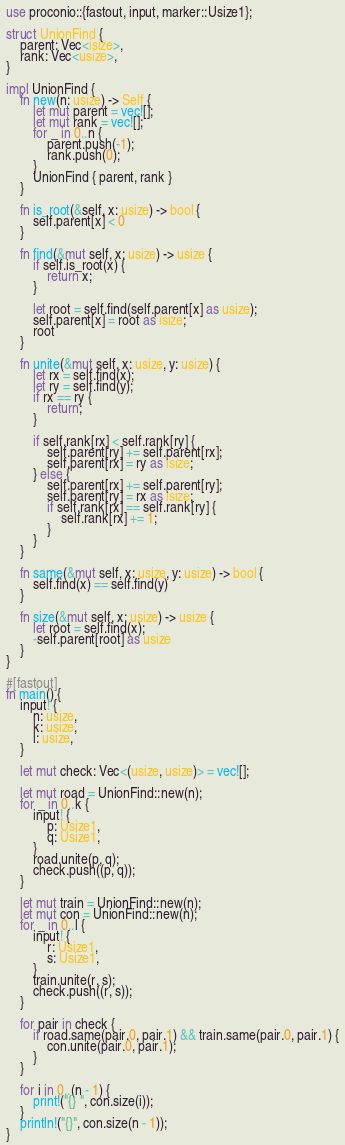<code> <loc_0><loc_0><loc_500><loc_500><_Rust_>use proconio::{fastout, input, marker::Usize1};

struct UnionFind {
    parent: Vec<isize>,
    rank: Vec<usize>,
}

impl UnionFind {
    fn new(n: usize) -> Self {
        let mut parent = vec![];
        let mut rank = vec![];
        for _ in 0..n {
            parent.push(-1);
            rank.push(0);
        }
        UnionFind { parent, rank }
    }

    fn is_root(&self, x: usize) -> bool {
        self.parent[x] < 0
    }

    fn find(&mut self, x: usize) -> usize {
        if self.is_root(x) {
            return x;
        }

        let root = self.find(self.parent[x] as usize);
        self.parent[x] = root as isize;
        root
    }

    fn unite(&mut self, x: usize, y: usize) {
        let rx = self.find(x);
        let ry = self.find(y);
        if rx == ry {
            return;
        }

        if self.rank[rx] < self.rank[ry] {
            self.parent[ry] += self.parent[rx];
            self.parent[rx] = ry as isize;
        } else {
            self.parent[rx] += self.parent[ry];
            self.parent[ry] = rx as isize;
            if self.rank[rx] == self.rank[ry] {
                self.rank[rx] += 1;
            }
        }
    }

    fn same(&mut self, x: usize, y: usize) -> bool {
        self.find(x) == self.find(y)
    }

    fn size(&mut self, x: usize) -> usize {
        let root = self.find(x);
        -self.parent[root] as usize
    }
}

#[fastout]
fn main() {
    input! {
        n: usize,
        k: usize,
        l: usize,
    }

    let mut check: Vec<(usize, usize)> = vec![];

    let mut road = UnionFind::new(n);
    for _ in 0..k {
        input! {
            p: Usize1,
            q: Usize1,
        }
        road.unite(p, q);
        check.push((p, q));
    }

    let mut train = UnionFind::new(n);
    let mut con = UnionFind::new(n);
    for _ in 0..l {
        input! {
            r: Usize1,
            s: Usize1,
        }
        train.unite(r, s);
        check.push((r, s));
    }

    for pair in check {
        if road.same(pair.0, pair.1) && train.same(pair.0, pair.1) {
            con.unite(pair.0, pair.1);
        }
    }

    for i in 0..(n - 1) {
        print!("{} ", con.size(i));
    }
    println!("{}", con.size(n - 1));
}
</code> 